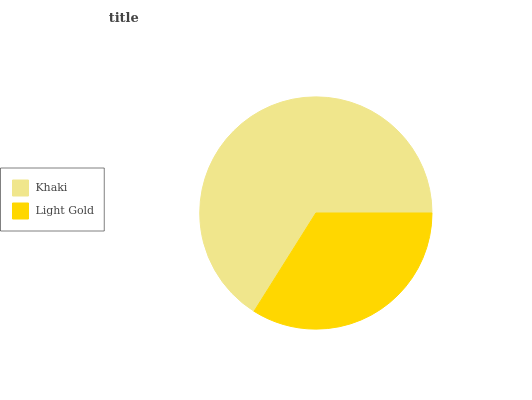Is Light Gold the minimum?
Answer yes or no. Yes. Is Khaki the maximum?
Answer yes or no. Yes. Is Light Gold the maximum?
Answer yes or no. No. Is Khaki greater than Light Gold?
Answer yes or no. Yes. Is Light Gold less than Khaki?
Answer yes or no. Yes. Is Light Gold greater than Khaki?
Answer yes or no. No. Is Khaki less than Light Gold?
Answer yes or no. No. Is Khaki the high median?
Answer yes or no. Yes. Is Light Gold the low median?
Answer yes or no. Yes. Is Light Gold the high median?
Answer yes or no. No. Is Khaki the low median?
Answer yes or no. No. 